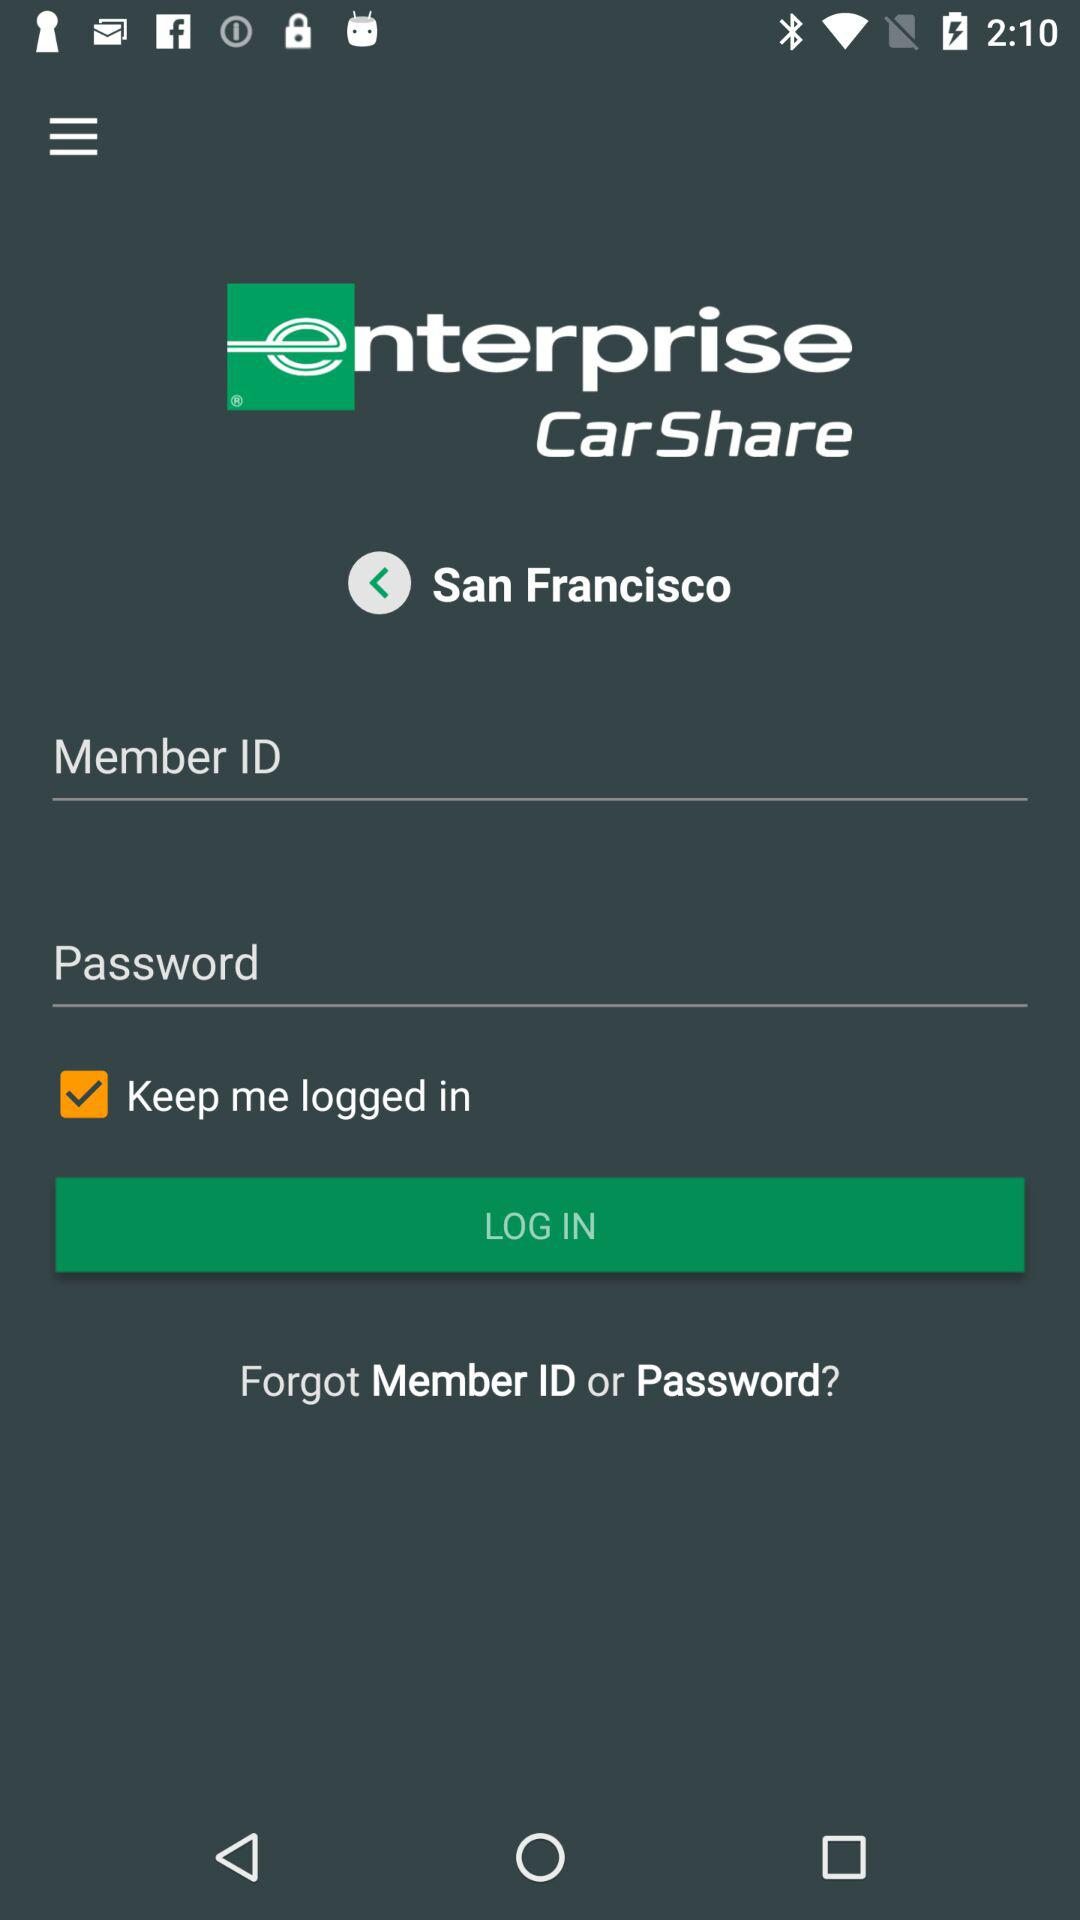What is the status of "Keep me logged in"? The status is on. 